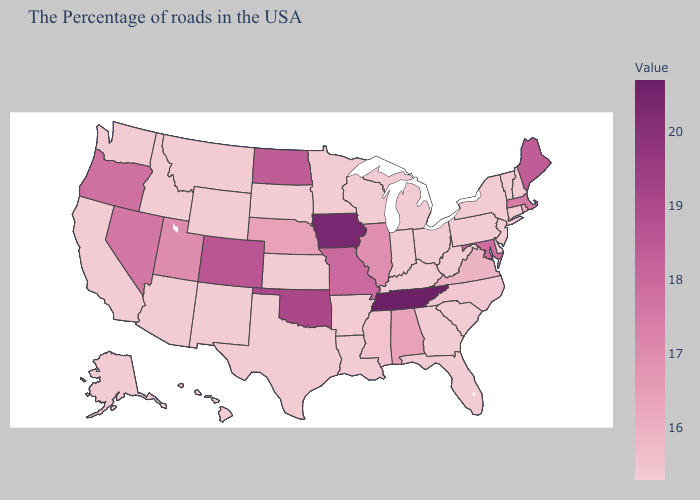Among the states that border Delaware , does Maryland have the lowest value?
Concise answer only. No. 